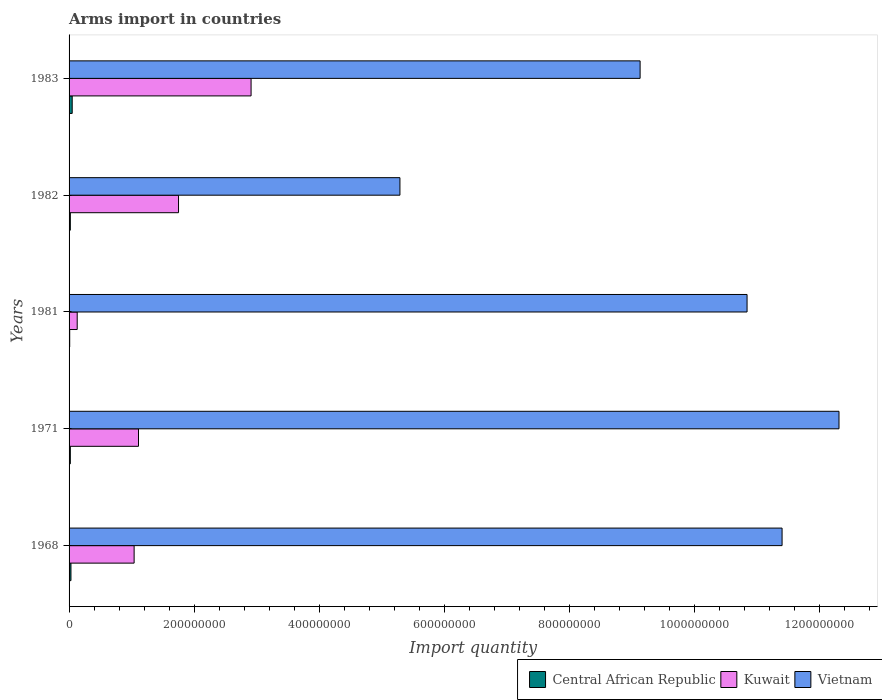How many different coloured bars are there?
Offer a very short reply. 3. Are the number of bars per tick equal to the number of legend labels?
Your response must be concise. Yes. Are the number of bars on each tick of the Y-axis equal?
Your response must be concise. Yes. How many bars are there on the 5th tick from the top?
Give a very brief answer. 3. What is the label of the 2nd group of bars from the top?
Give a very brief answer. 1982. What is the total arms import in Vietnam in 1983?
Your answer should be very brief. 9.13e+08. Across all years, what is the maximum total arms import in Vietnam?
Ensure brevity in your answer.  1.23e+09. Across all years, what is the minimum total arms import in Central African Republic?
Offer a terse response. 1.00e+06. In which year was the total arms import in Kuwait minimum?
Make the answer very short. 1981. What is the total total arms import in Central African Republic in the graph?
Offer a very short reply. 1.30e+07. What is the difference between the total arms import in Kuwait in 1968 and that in 1983?
Provide a short and direct response. -1.87e+08. What is the difference between the total arms import in Central African Republic in 1981 and the total arms import in Vietnam in 1982?
Provide a succinct answer. -5.28e+08. What is the average total arms import in Kuwait per year?
Provide a short and direct response. 1.39e+08. In the year 1971, what is the difference between the total arms import in Kuwait and total arms import in Central African Republic?
Your answer should be very brief. 1.09e+08. In how many years, is the total arms import in Kuwait greater than 1160000000 ?
Your answer should be very brief. 0. What is the ratio of the total arms import in Vietnam in 1981 to that in 1982?
Your answer should be compact. 2.05. Is the difference between the total arms import in Kuwait in 1971 and 1982 greater than the difference between the total arms import in Central African Republic in 1971 and 1982?
Make the answer very short. No. What is the difference between the highest and the second highest total arms import in Kuwait?
Make the answer very short. 1.16e+08. What is the difference between the highest and the lowest total arms import in Central African Republic?
Your answer should be compact. 4.00e+06. Is the sum of the total arms import in Vietnam in 1971 and 1983 greater than the maximum total arms import in Kuwait across all years?
Provide a short and direct response. Yes. What does the 3rd bar from the top in 1968 represents?
Keep it short and to the point. Central African Republic. What does the 1st bar from the bottom in 1981 represents?
Keep it short and to the point. Central African Republic. How many bars are there?
Offer a terse response. 15. Are all the bars in the graph horizontal?
Provide a short and direct response. Yes. How many years are there in the graph?
Your answer should be compact. 5. Are the values on the major ticks of X-axis written in scientific E-notation?
Your response must be concise. No. Does the graph contain grids?
Ensure brevity in your answer.  No. Where does the legend appear in the graph?
Your answer should be compact. Bottom right. How many legend labels are there?
Make the answer very short. 3. How are the legend labels stacked?
Offer a terse response. Horizontal. What is the title of the graph?
Your answer should be very brief. Arms import in countries. Does "Colombia" appear as one of the legend labels in the graph?
Offer a very short reply. No. What is the label or title of the X-axis?
Ensure brevity in your answer.  Import quantity. What is the label or title of the Y-axis?
Offer a very short reply. Years. What is the Import quantity of Kuwait in 1968?
Offer a terse response. 1.04e+08. What is the Import quantity of Vietnam in 1968?
Make the answer very short. 1.14e+09. What is the Import quantity in Kuwait in 1971?
Provide a succinct answer. 1.11e+08. What is the Import quantity in Vietnam in 1971?
Keep it short and to the point. 1.23e+09. What is the Import quantity in Central African Republic in 1981?
Offer a terse response. 1.00e+06. What is the Import quantity in Kuwait in 1981?
Provide a succinct answer. 1.30e+07. What is the Import quantity in Vietnam in 1981?
Ensure brevity in your answer.  1.08e+09. What is the Import quantity of Kuwait in 1982?
Offer a very short reply. 1.75e+08. What is the Import quantity in Vietnam in 1982?
Offer a terse response. 5.29e+08. What is the Import quantity in Central African Republic in 1983?
Your response must be concise. 5.00e+06. What is the Import quantity of Kuwait in 1983?
Your response must be concise. 2.91e+08. What is the Import quantity in Vietnam in 1983?
Your answer should be very brief. 9.13e+08. Across all years, what is the maximum Import quantity in Kuwait?
Make the answer very short. 2.91e+08. Across all years, what is the maximum Import quantity in Vietnam?
Ensure brevity in your answer.  1.23e+09. Across all years, what is the minimum Import quantity in Central African Republic?
Offer a terse response. 1.00e+06. Across all years, what is the minimum Import quantity in Kuwait?
Offer a very short reply. 1.30e+07. Across all years, what is the minimum Import quantity in Vietnam?
Offer a terse response. 5.29e+08. What is the total Import quantity of Central African Republic in the graph?
Your response must be concise. 1.30e+07. What is the total Import quantity of Kuwait in the graph?
Ensure brevity in your answer.  6.94e+08. What is the total Import quantity of Vietnam in the graph?
Your answer should be very brief. 4.90e+09. What is the difference between the Import quantity of Central African Republic in 1968 and that in 1971?
Offer a terse response. 1.00e+06. What is the difference between the Import quantity of Kuwait in 1968 and that in 1971?
Ensure brevity in your answer.  -7.00e+06. What is the difference between the Import quantity in Vietnam in 1968 and that in 1971?
Your answer should be very brief. -9.10e+07. What is the difference between the Import quantity of Central African Republic in 1968 and that in 1981?
Give a very brief answer. 2.00e+06. What is the difference between the Import quantity of Kuwait in 1968 and that in 1981?
Your response must be concise. 9.10e+07. What is the difference between the Import quantity in Vietnam in 1968 and that in 1981?
Keep it short and to the point. 5.60e+07. What is the difference between the Import quantity of Kuwait in 1968 and that in 1982?
Your answer should be very brief. -7.10e+07. What is the difference between the Import quantity in Vietnam in 1968 and that in 1982?
Ensure brevity in your answer.  6.11e+08. What is the difference between the Import quantity of Central African Republic in 1968 and that in 1983?
Provide a succinct answer. -2.00e+06. What is the difference between the Import quantity of Kuwait in 1968 and that in 1983?
Your answer should be compact. -1.87e+08. What is the difference between the Import quantity of Vietnam in 1968 and that in 1983?
Your response must be concise. 2.27e+08. What is the difference between the Import quantity in Kuwait in 1971 and that in 1981?
Provide a short and direct response. 9.80e+07. What is the difference between the Import quantity of Vietnam in 1971 and that in 1981?
Offer a terse response. 1.47e+08. What is the difference between the Import quantity of Central African Republic in 1971 and that in 1982?
Offer a terse response. 0. What is the difference between the Import quantity in Kuwait in 1971 and that in 1982?
Give a very brief answer. -6.40e+07. What is the difference between the Import quantity in Vietnam in 1971 and that in 1982?
Offer a terse response. 7.02e+08. What is the difference between the Import quantity of Kuwait in 1971 and that in 1983?
Keep it short and to the point. -1.80e+08. What is the difference between the Import quantity in Vietnam in 1971 and that in 1983?
Your answer should be very brief. 3.18e+08. What is the difference between the Import quantity of Central African Republic in 1981 and that in 1982?
Your answer should be very brief. -1.00e+06. What is the difference between the Import quantity of Kuwait in 1981 and that in 1982?
Give a very brief answer. -1.62e+08. What is the difference between the Import quantity of Vietnam in 1981 and that in 1982?
Your response must be concise. 5.55e+08. What is the difference between the Import quantity in Kuwait in 1981 and that in 1983?
Ensure brevity in your answer.  -2.78e+08. What is the difference between the Import quantity of Vietnam in 1981 and that in 1983?
Provide a short and direct response. 1.71e+08. What is the difference between the Import quantity of Kuwait in 1982 and that in 1983?
Keep it short and to the point. -1.16e+08. What is the difference between the Import quantity of Vietnam in 1982 and that in 1983?
Provide a succinct answer. -3.84e+08. What is the difference between the Import quantity in Central African Republic in 1968 and the Import quantity in Kuwait in 1971?
Your answer should be very brief. -1.08e+08. What is the difference between the Import quantity of Central African Republic in 1968 and the Import quantity of Vietnam in 1971?
Offer a terse response. -1.23e+09. What is the difference between the Import quantity of Kuwait in 1968 and the Import quantity of Vietnam in 1971?
Your response must be concise. -1.13e+09. What is the difference between the Import quantity of Central African Republic in 1968 and the Import quantity of Kuwait in 1981?
Your response must be concise. -1.00e+07. What is the difference between the Import quantity in Central African Republic in 1968 and the Import quantity in Vietnam in 1981?
Offer a terse response. -1.08e+09. What is the difference between the Import quantity in Kuwait in 1968 and the Import quantity in Vietnam in 1981?
Ensure brevity in your answer.  -9.80e+08. What is the difference between the Import quantity in Central African Republic in 1968 and the Import quantity in Kuwait in 1982?
Provide a succinct answer. -1.72e+08. What is the difference between the Import quantity in Central African Republic in 1968 and the Import quantity in Vietnam in 1982?
Provide a short and direct response. -5.26e+08. What is the difference between the Import quantity in Kuwait in 1968 and the Import quantity in Vietnam in 1982?
Provide a short and direct response. -4.25e+08. What is the difference between the Import quantity in Central African Republic in 1968 and the Import quantity in Kuwait in 1983?
Offer a very short reply. -2.88e+08. What is the difference between the Import quantity of Central African Republic in 1968 and the Import quantity of Vietnam in 1983?
Offer a very short reply. -9.10e+08. What is the difference between the Import quantity of Kuwait in 1968 and the Import quantity of Vietnam in 1983?
Offer a terse response. -8.09e+08. What is the difference between the Import quantity in Central African Republic in 1971 and the Import quantity in Kuwait in 1981?
Provide a succinct answer. -1.10e+07. What is the difference between the Import quantity in Central African Republic in 1971 and the Import quantity in Vietnam in 1981?
Give a very brief answer. -1.08e+09. What is the difference between the Import quantity of Kuwait in 1971 and the Import quantity of Vietnam in 1981?
Offer a terse response. -9.73e+08. What is the difference between the Import quantity in Central African Republic in 1971 and the Import quantity in Kuwait in 1982?
Keep it short and to the point. -1.73e+08. What is the difference between the Import quantity in Central African Republic in 1971 and the Import quantity in Vietnam in 1982?
Offer a terse response. -5.27e+08. What is the difference between the Import quantity in Kuwait in 1971 and the Import quantity in Vietnam in 1982?
Provide a succinct answer. -4.18e+08. What is the difference between the Import quantity of Central African Republic in 1971 and the Import quantity of Kuwait in 1983?
Provide a short and direct response. -2.89e+08. What is the difference between the Import quantity in Central African Republic in 1971 and the Import quantity in Vietnam in 1983?
Provide a succinct answer. -9.11e+08. What is the difference between the Import quantity of Kuwait in 1971 and the Import quantity of Vietnam in 1983?
Ensure brevity in your answer.  -8.02e+08. What is the difference between the Import quantity in Central African Republic in 1981 and the Import quantity in Kuwait in 1982?
Your response must be concise. -1.74e+08. What is the difference between the Import quantity of Central African Republic in 1981 and the Import quantity of Vietnam in 1982?
Your answer should be compact. -5.28e+08. What is the difference between the Import quantity in Kuwait in 1981 and the Import quantity in Vietnam in 1982?
Provide a short and direct response. -5.16e+08. What is the difference between the Import quantity in Central African Republic in 1981 and the Import quantity in Kuwait in 1983?
Your answer should be compact. -2.90e+08. What is the difference between the Import quantity of Central African Republic in 1981 and the Import quantity of Vietnam in 1983?
Provide a short and direct response. -9.12e+08. What is the difference between the Import quantity of Kuwait in 1981 and the Import quantity of Vietnam in 1983?
Give a very brief answer. -9.00e+08. What is the difference between the Import quantity of Central African Republic in 1982 and the Import quantity of Kuwait in 1983?
Provide a short and direct response. -2.89e+08. What is the difference between the Import quantity of Central African Republic in 1982 and the Import quantity of Vietnam in 1983?
Ensure brevity in your answer.  -9.11e+08. What is the difference between the Import quantity of Kuwait in 1982 and the Import quantity of Vietnam in 1983?
Your response must be concise. -7.38e+08. What is the average Import quantity of Central African Republic per year?
Offer a very short reply. 2.60e+06. What is the average Import quantity in Kuwait per year?
Your response must be concise. 1.39e+08. What is the average Import quantity of Vietnam per year?
Offer a very short reply. 9.79e+08. In the year 1968, what is the difference between the Import quantity of Central African Republic and Import quantity of Kuwait?
Your answer should be compact. -1.01e+08. In the year 1968, what is the difference between the Import quantity of Central African Republic and Import quantity of Vietnam?
Keep it short and to the point. -1.14e+09. In the year 1968, what is the difference between the Import quantity of Kuwait and Import quantity of Vietnam?
Your response must be concise. -1.04e+09. In the year 1971, what is the difference between the Import quantity of Central African Republic and Import quantity of Kuwait?
Give a very brief answer. -1.09e+08. In the year 1971, what is the difference between the Import quantity of Central African Republic and Import quantity of Vietnam?
Your answer should be very brief. -1.23e+09. In the year 1971, what is the difference between the Import quantity in Kuwait and Import quantity in Vietnam?
Keep it short and to the point. -1.12e+09. In the year 1981, what is the difference between the Import quantity in Central African Republic and Import quantity in Kuwait?
Your response must be concise. -1.20e+07. In the year 1981, what is the difference between the Import quantity in Central African Republic and Import quantity in Vietnam?
Offer a very short reply. -1.08e+09. In the year 1981, what is the difference between the Import quantity in Kuwait and Import quantity in Vietnam?
Offer a very short reply. -1.07e+09. In the year 1982, what is the difference between the Import quantity in Central African Republic and Import quantity in Kuwait?
Provide a short and direct response. -1.73e+08. In the year 1982, what is the difference between the Import quantity of Central African Republic and Import quantity of Vietnam?
Provide a short and direct response. -5.27e+08. In the year 1982, what is the difference between the Import quantity in Kuwait and Import quantity in Vietnam?
Provide a succinct answer. -3.54e+08. In the year 1983, what is the difference between the Import quantity in Central African Republic and Import quantity in Kuwait?
Provide a succinct answer. -2.86e+08. In the year 1983, what is the difference between the Import quantity of Central African Republic and Import quantity of Vietnam?
Provide a succinct answer. -9.08e+08. In the year 1983, what is the difference between the Import quantity of Kuwait and Import quantity of Vietnam?
Provide a short and direct response. -6.22e+08. What is the ratio of the Import quantity of Kuwait in 1968 to that in 1971?
Give a very brief answer. 0.94. What is the ratio of the Import quantity of Vietnam in 1968 to that in 1971?
Give a very brief answer. 0.93. What is the ratio of the Import quantity in Vietnam in 1968 to that in 1981?
Offer a terse response. 1.05. What is the ratio of the Import quantity in Central African Republic in 1968 to that in 1982?
Offer a very short reply. 1.5. What is the ratio of the Import quantity of Kuwait in 1968 to that in 1982?
Your response must be concise. 0.59. What is the ratio of the Import quantity in Vietnam in 1968 to that in 1982?
Keep it short and to the point. 2.15. What is the ratio of the Import quantity of Kuwait in 1968 to that in 1983?
Offer a terse response. 0.36. What is the ratio of the Import quantity of Vietnam in 1968 to that in 1983?
Offer a very short reply. 1.25. What is the ratio of the Import quantity of Central African Republic in 1971 to that in 1981?
Provide a short and direct response. 2. What is the ratio of the Import quantity of Kuwait in 1971 to that in 1981?
Your answer should be compact. 8.54. What is the ratio of the Import quantity of Vietnam in 1971 to that in 1981?
Provide a short and direct response. 1.14. What is the ratio of the Import quantity of Central African Republic in 1971 to that in 1982?
Make the answer very short. 1. What is the ratio of the Import quantity of Kuwait in 1971 to that in 1982?
Offer a very short reply. 0.63. What is the ratio of the Import quantity in Vietnam in 1971 to that in 1982?
Keep it short and to the point. 2.33. What is the ratio of the Import quantity in Central African Republic in 1971 to that in 1983?
Keep it short and to the point. 0.4. What is the ratio of the Import quantity of Kuwait in 1971 to that in 1983?
Give a very brief answer. 0.38. What is the ratio of the Import quantity in Vietnam in 1971 to that in 1983?
Your answer should be compact. 1.35. What is the ratio of the Import quantity of Central African Republic in 1981 to that in 1982?
Your answer should be compact. 0.5. What is the ratio of the Import quantity of Kuwait in 1981 to that in 1982?
Offer a very short reply. 0.07. What is the ratio of the Import quantity in Vietnam in 1981 to that in 1982?
Provide a succinct answer. 2.05. What is the ratio of the Import quantity in Kuwait in 1981 to that in 1983?
Provide a short and direct response. 0.04. What is the ratio of the Import quantity in Vietnam in 1981 to that in 1983?
Your answer should be compact. 1.19. What is the ratio of the Import quantity in Kuwait in 1982 to that in 1983?
Your response must be concise. 0.6. What is the ratio of the Import quantity in Vietnam in 1982 to that in 1983?
Provide a short and direct response. 0.58. What is the difference between the highest and the second highest Import quantity of Central African Republic?
Offer a very short reply. 2.00e+06. What is the difference between the highest and the second highest Import quantity of Kuwait?
Provide a succinct answer. 1.16e+08. What is the difference between the highest and the second highest Import quantity of Vietnam?
Provide a short and direct response. 9.10e+07. What is the difference between the highest and the lowest Import quantity of Kuwait?
Make the answer very short. 2.78e+08. What is the difference between the highest and the lowest Import quantity in Vietnam?
Keep it short and to the point. 7.02e+08. 